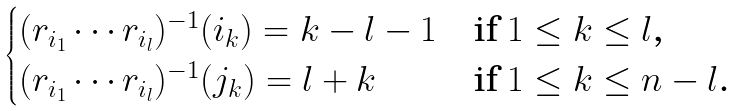<formula> <loc_0><loc_0><loc_500><loc_500>\begin{cases} ( r _ { i _ { 1 } } \cdots r _ { i _ { l } } ) ^ { - 1 } ( i _ { k } ) = k - l - 1 & \text {if $1 \leq k \leq l$,} \\ ( r _ { i _ { 1 } } \cdots r _ { i _ { l } } ) ^ { - 1 } ( j _ { k } ) = l + k & \text {if $1 \leq k \leq n-l$.} \\ \end{cases}</formula> 